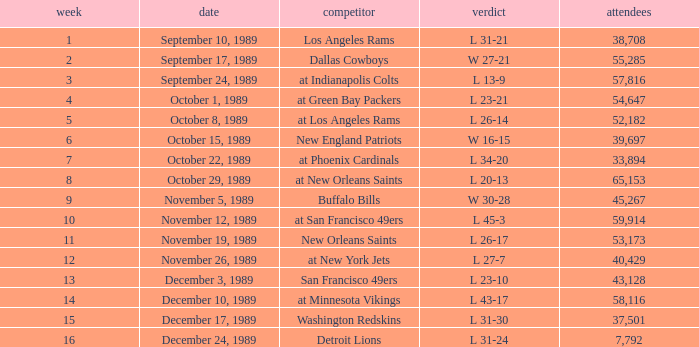On September 10, 1989 how many people attended the game? 38708.0. 